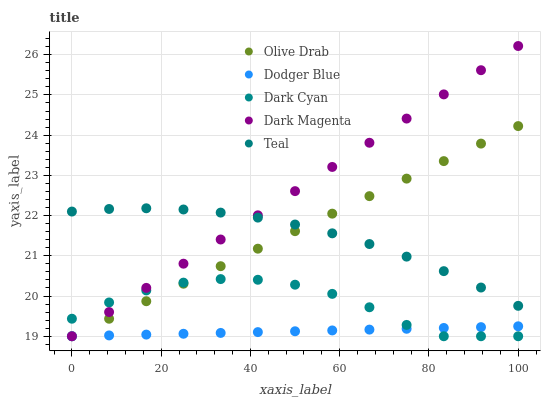Does Dodger Blue have the minimum area under the curve?
Answer yes or no. Yes. Does Dark Magenta have the maximum area under the curve?
Answer yes or no. Yes. Does Teal have the minimum area under the curve?
Answer yes or no. No. Does Teal have the maximum area under the curve?
Answer yes or no. No. Is Dodger Blue the smoothest?
Answer yes or no. Yes. Is Dark Cyan the roughest?
Answer yes or no. Yes. Is Teal the smoothest?
Answer yes or no. No. Is Teal the roughest?
Answer yes or no. No. Does Dark Cyan have the lowest value?
Answer yes or no. Yes. Does Teal have the lowest value?
Answer yes or no. No. Does Dark Magenta have the highest value?
Answer yes or no. Yes. Does Teal have the highest value?
Answer yes or no. No. Is Dodger Blue less than Teal?
Answer yes or no. Yes. Is Teal greater than Dodger Blue?
Answer yes or no. Yes. Does Olive Drab intersect Dark Cyan?
Answer yes or no. Yes. Is Olive Drab less than Dark Cyan?
Answer yes or no. No. Is Olive Drab greater than Dark Cyan?
Answer yes or no. No. Does Dodger Blue intersect Teal?
Answer yes or no. No. 